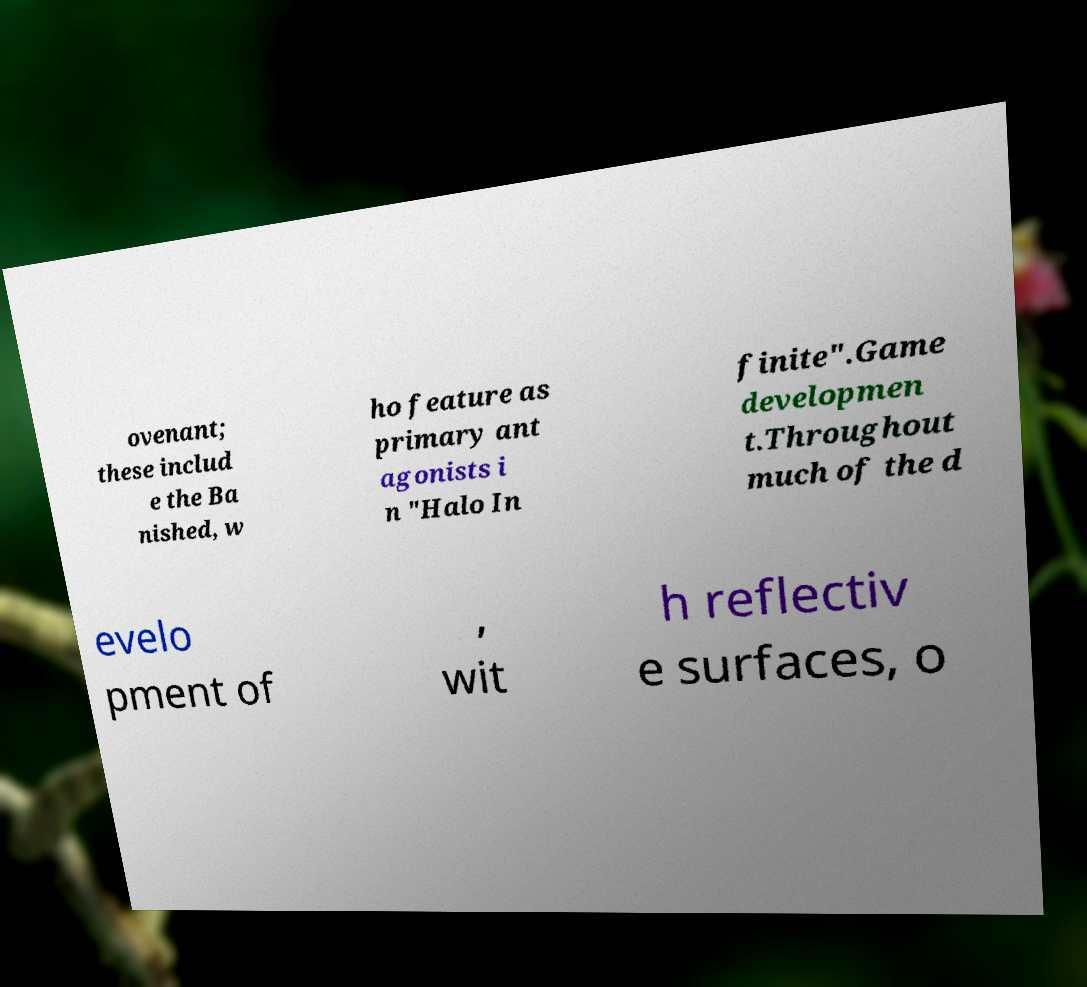Please read and relay the text visible in this image. What does it say? ovenant; these includ e the Ba nished, w ho feature as primary ant agonists i n "Halo In finite".Game developmen t.Throughout much of the d evelo pment of , wit h reflectiv e surfaces, o 